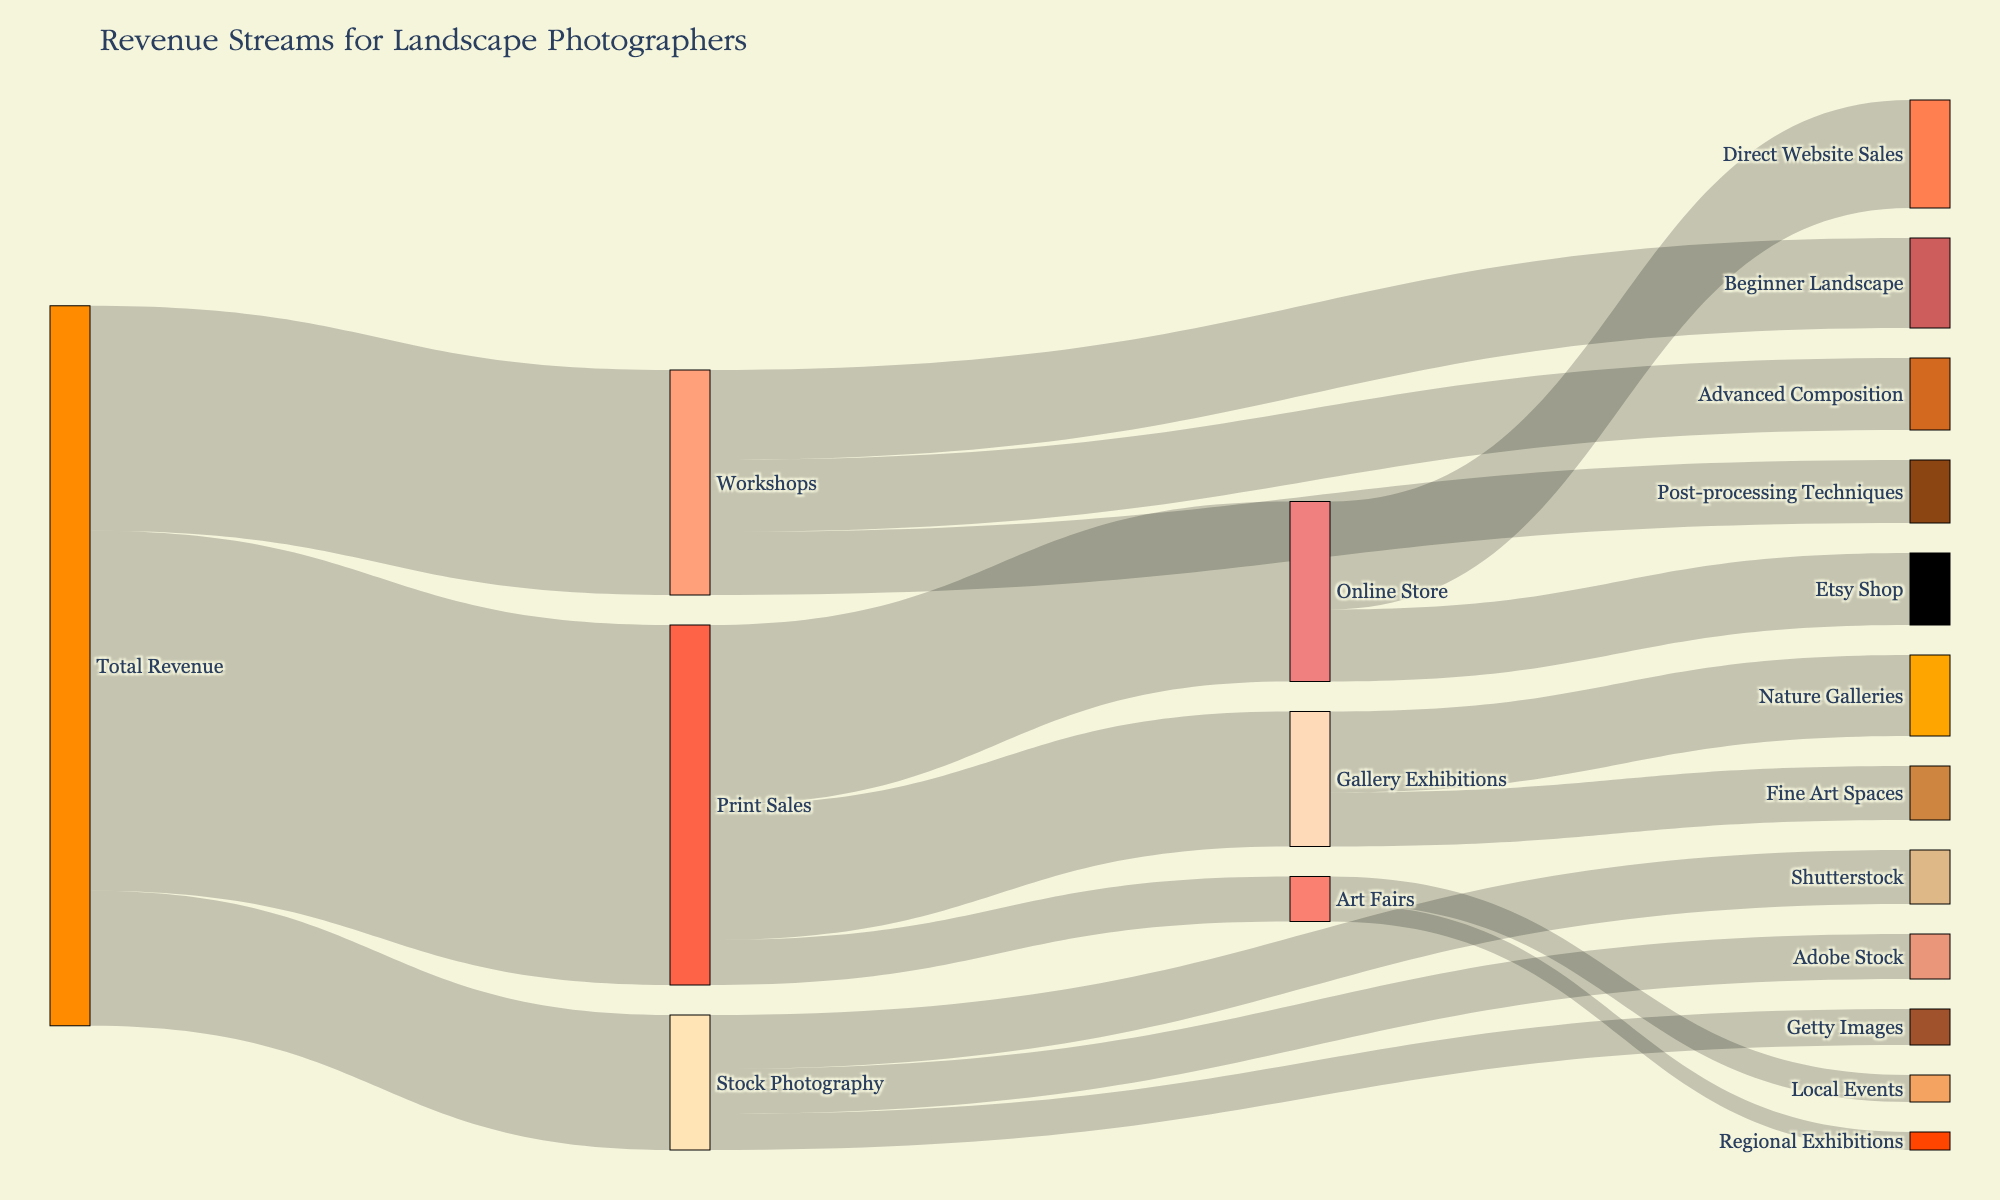who generates the most revenue: print sales, workshops, or stock photography? The segments for each revenue stream connected to "Total Revenue" show their individual values. Print sales are $40,000; workshops are $25,000; stock photography is $15,000. Comparing the values, print sales generate the most revenue.
Answer: Print sales how much revenue comes from the combination of beginner landscape and advanced composition workshops? The value for beginner landscape workshops is $10,000 and for advanced composition is $8,000. Adding these together yields $18,000.
Answer: $18,000 which source contributes more revenue to print sales: gallery exhibitions or online store? Observe the segments connected from print sales to both gallery exhibitions and online store. Gallery exhibitions contribute $15,000, and online store contributes $20,000. The online store contributes more.
Answer: Online store what is the total revenue derived from stock photography? Summing up the contributions from Shutterstock ($6,000), Adobe Stock ($5,000), and Getty Images ($4,000) results in a total of $15,000.
Answer: $15,000 how does revenue from local events compare to regional exhibitions within art fairs? The revenue from local events is $3,000, and from regional exhibitions, it is $2,000. Local events contribute a larger amount.
Answer: Local events which node in the online store has a higher revenue: direct website sales or Etsy shop? Direct website sales have $12,000 and Etsy shop has $8,000. Direct website sales have a higher revenue.
Answer: Direct website sales how much total revenue comes from gallery exhibitions, combining nature galleries and fine art spaces? Nature galleries have $9,000 and fine art spaces have $6,000. Combined, they have a total revenue of $15,000.
Answer: $15,000 which type of workshops generates the least revenue? Comparing the three types of workshops: beginner landscape ($10,000), advanced composition ($8,000), and post-processing techniques ($7,000), post-processing techniques generate the least revenue.
Answer: Post-processing techniques is the revenue from Adobe Stock higher or lower than from Getty Images? Adobe Stock generates $5,000, while Getty Images generates $4,000. Adobe Stock's revenue is higher.
Answer: Higher what is the combined revenue from all types of print sales outlets (gallery exhibitions, online store, art fairs)? Adding revenues from gallery exhibitions ($15,000), online store ($20,000), and art fairs ($5,000) totals $40,000.
Answer: $40,000 